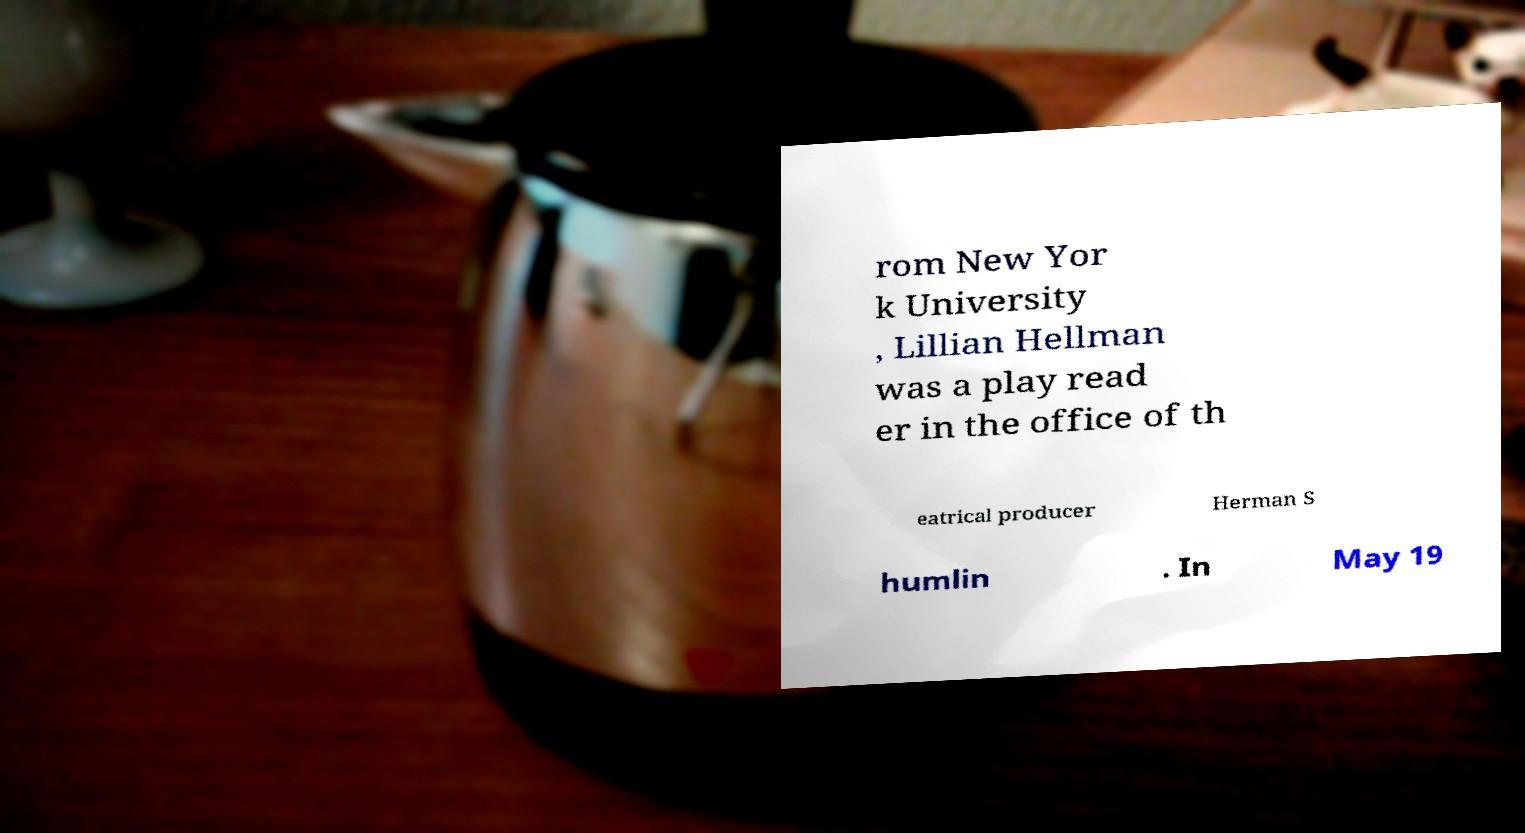I need the written content from this picture converted into text. Can you do that? rom New Yor k University , Lillian Hellman was a play read er in the office of th eatrical producer Herman S humlin . In May 19 